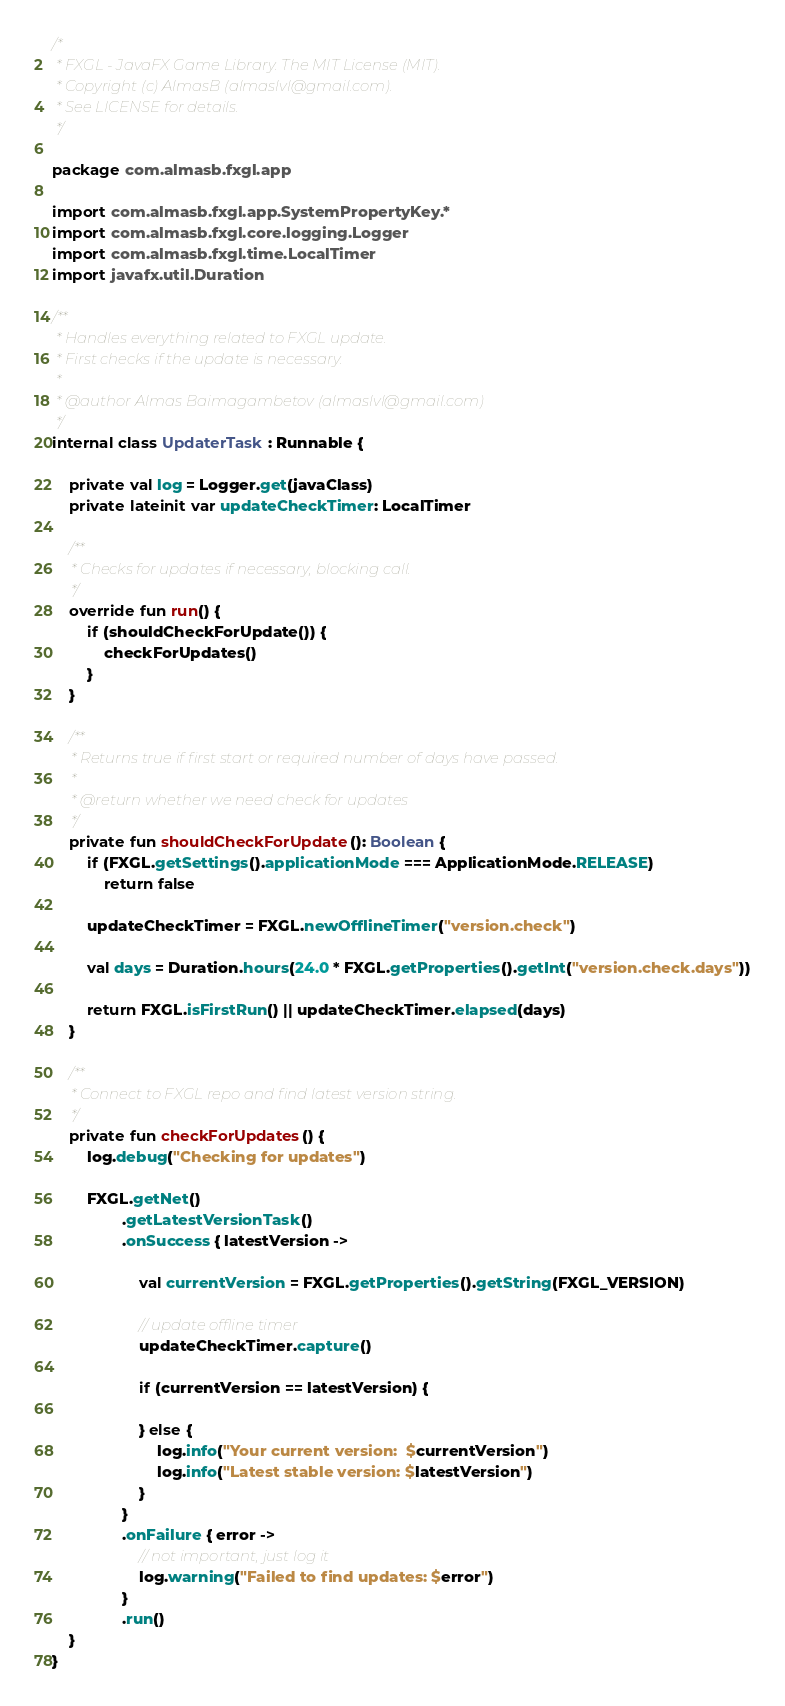<code> <loc_0><loc_0><loc_500><loc_500><_Kotlin_>/*
 * FXGL - JavaFX Game Library. The MIT License (MIT).
 * Copyright (c) AlmasB (almaslvl@gmail.com).
 * See LICENSE for details.
 */

package com.almasb.fxgl.app

import com.almasb.fxgl.app.SystemPropertyKey.*
import com.almasb.fxgl.core.logging.Logger
import com.almasb.fxgl.time.LocalTimer
import javafx.util.Duration

/**
 * Handles everything related to FXGL update.
 * First checks if the update is necessary.
 *
 * @author Almas Baimagambetov (almaslvl@gmail.com)
 */
internal class UpdaterTask : Runnable {

    private val log = Logger.get(javaClass)
    private lateinit var updateCheckTimer: LocalTimer

    /**
     * Checks for updates if necessary, blocking call.
     */
    override fun run() {
        if (shouldCheckForUpdate()) {
            checkForUpdates()
        }
    }

    /**
     * Returns true if first start or required number of days have passed.
     *
     * @return whether we need check for updates
     */
    private fun shouldCheckForUpdate(): Boolean {
        if (FXGL.getSettings().applicationMode === ApplicationMode.RELEASE)
            return false

        updateCheckTimer = FXGL.newOfflineTimer("version.check")

        val days = Duration.hours(24.0 * FXGL.getProperties().getInt("version.check.days"))

        return FXGL.isFirstRun() || updateCheckTimer.elapsed(days)
    }

    /**
     * Connect to FXGL repo and find latest version string.
     */
    private fun checkForUpdates() {
        log.debug("Checking for updates")

        FXGL.getNet()
                .getLatestVersionTask()
                .onSuccess { latestVersion ->

                    val currentVersion = FXGL.getProperties().getString(FXGL_VERSION)

                    // update offline timer
                    updateCheckTimer.capture()

                    if (currentVersion == latestVersion) {

                    } else {
                        log.info("Your current version:  $currentVersion")
                        log.info("Latest stable version: $latestVersion")
                    }
                }
                .onFailure { error ->
                    // not important, just log it
                    log.warning("Failed to find updates: $error")
                }
                .run()
    }
}</code> 